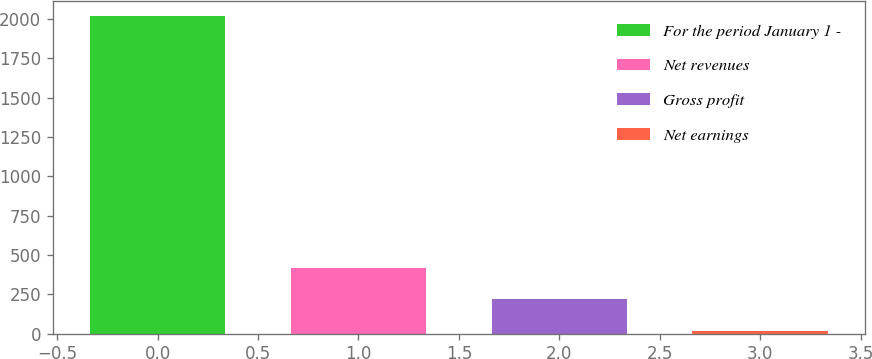Convert chart to OTSL. <chart><loc_0><loc_0><loc_500><loc_500><bar_chart><fcel>For the period January 1 -<fcel>Net revenues<fcel>Gross profit<fcel>Net earnings<nl><fcel>2016<fcel>419.44<fcel>219.87<fcel>20.3<nl></chart> 